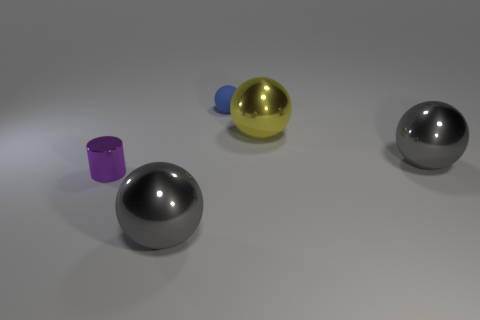There is a cylinder; is it the same size as the gray object that is on the right side of the small blue thing?
Offer a very short reply. No. There is a small thing that is behind the gray sphere on the right side of the small blue matte sphere; what is it made of?
Ensure brevity in your answer.  Rubber. There is a gray object that is in front of the gray sphere that is on the right side of the blue ball behind the small purple object; what size is it?
Make the answer very short. Large. Does the tiny blue matte object have the same shape as the tiny object in front of the blue ball?
Offer a terse response. No. What is the big yellow thing made of?
Make the answer very short. Metal. How many metallic objects are gray things or big red balls?
Ensure brevity in your answer.  2. Are there fewer gray metallic things that are to the left of the blue thing than metal objects left of the large yellow shiny thing?
Keep it short and to the point. Yes. Are there any small rubber balls in front of the big gray sphere that is in front of the purple thing that is in front of the tiny sphere?
Your response must be concise. No. Do the small blue object behind the tiny metallic object and the big thing to the left of the tiny blue matte thing have the same shape?
Offer a terse response. Yes. There is another object that is the same size as the purple object; what is it made of?
Give a very brief answer. Rubber. 